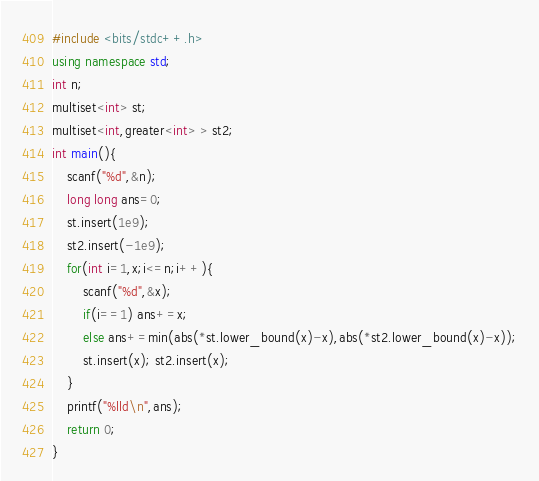<code> <loc_0><loc_0><loc_500><loc_500><_C++_>#include <bits/stdc++.h>
using namespace std;
int n;
multiset<int> st;
multiset<int,greater<int> > st2;
int main(){
	scanf("%d",&n);
	long long ans=0;
	st.insert(1e9);
	st2.insert(-1e9);
	for(int i=1,x;i<=n;i++){
		scanf("%d",&x);
		if(i==1) ans+=x;
		else ans+=min(abs(*st.lower_bound(x)-x),abs(*st2.lower_bound(x)-x));
		st.insert(x); st2.insert(x);
	}
	printf("%lld\n",ans);
	return 0;
}
</code> 